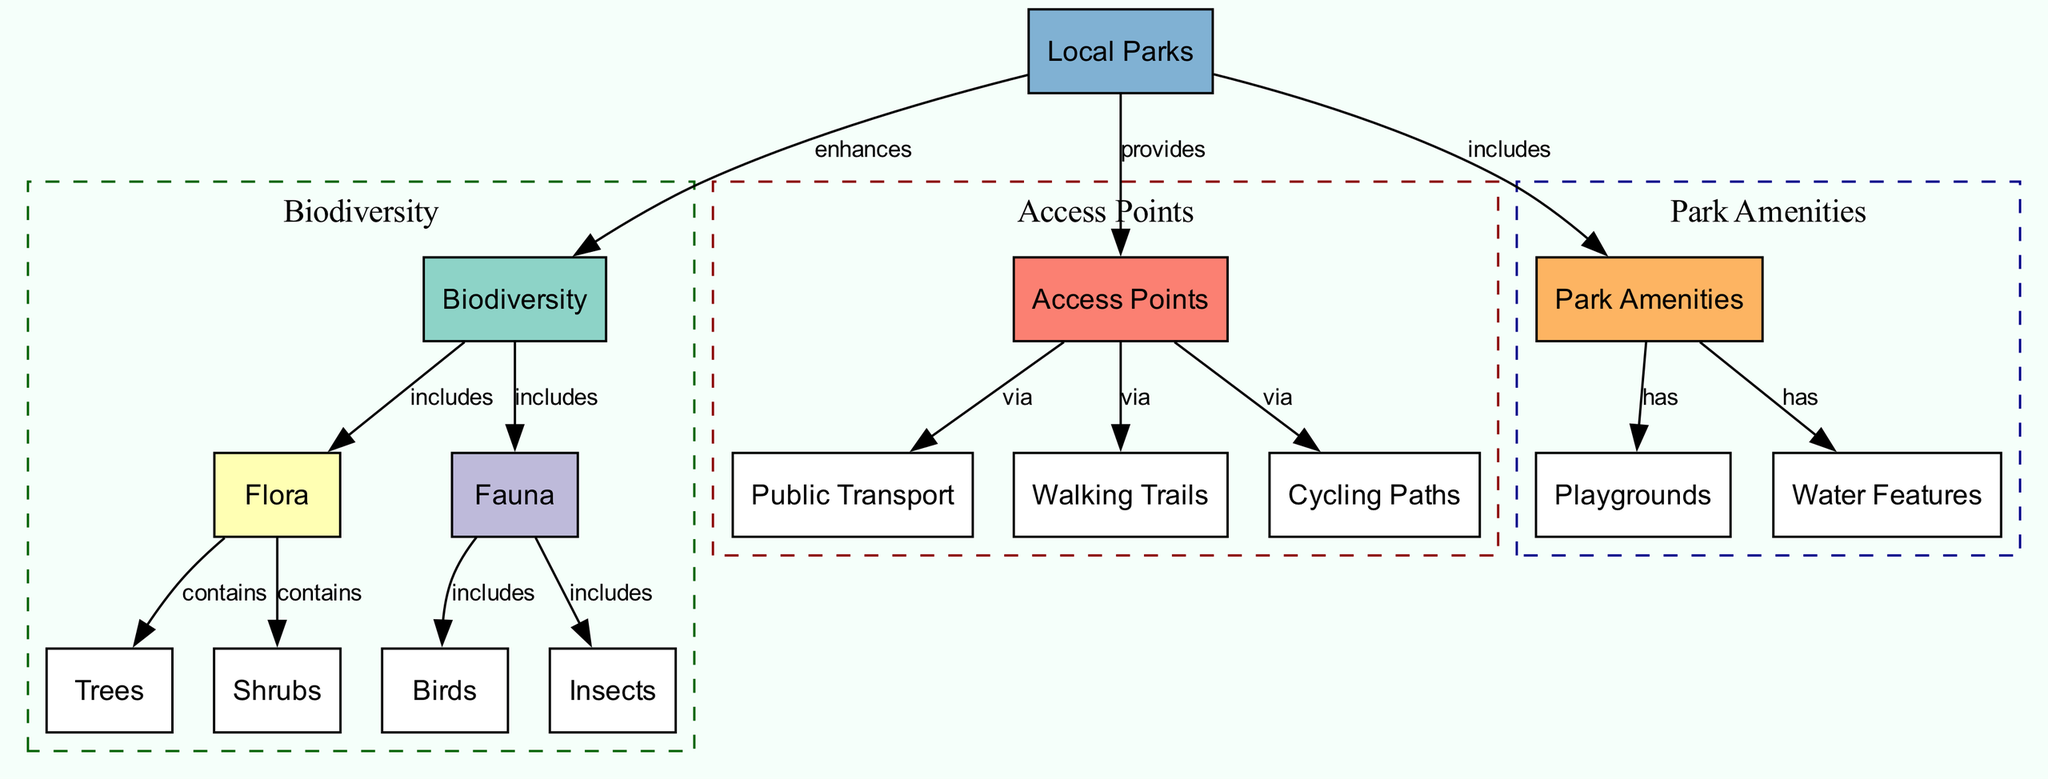What are the main components of biodiversity in the diagram? The main components of biodiversity as shown in the diagram are flora and fauna. These two categories are directly included in the "Biodiversity" node, which establishes their significance within the broader concept.
Answer: flora and fauna How many access points are listed in the diagram? The diagram displays one main node labeled "access points," which connects to public transport, walking trails, and cycling paths. It is calculated as the primary access facilitator without counting those sub-nodes, leading to a total of one access point.
Answer: 1 Which nodes are connected to the local parks node? The local parks node connects to three nodes: biodiversity, access points, and park amenities. The connections indicate that local parks enhance biodiversity, provide access points, and include park amenities, which encompass additional features and facilities.
Answer: biodiversity, access points, park amenities What flora categories are included under biodiversity? Within the biodiversity node, two specific flora categories are highlighted: trees and shrubs. These categories are described as elements that "contain" the broader topic of flora, emphasizing the variety of plant life in urban green spaces.
Answer: trees, shrubs Which access points are connected via walking trails? The walking trails node is a direct sub-node of access points, indicating that walking trails exist as one means of access to local parks. This established connection affirms walking trails as part of the pathway system available to park visitors.
Answer: walking trails How many species of fauna are listed in the biodiversity section? The biodiversity section mentions two species under fauna: birds and insects. This clearly defines the diversity of animal life present within the ecosystem of local parks, emphasizing the significance of fauna alongside flora.
Answer: 2 What amenities are included under park amenities? Under park amenities, two specific amenities are included: playgrounds and water features. This division highlights recreational and aesthetic elements that enhance the user experience in local parks, indicating their importance in community engagement.
Answer: playgrounds, water features What relationships exist between access points and local parks? The relationships highlight that access points provide connections to public transport, walking trails, and cycling paths, enhancing access to local parks. This indicates the importance of these access points for ensuring people can reach the parks conveniently.
Answer: provides Which node is the starting point for understanding park amenities? The starting point for understanding park amenities is the "park amenities" node itself. It directly connects to the specific amenities such as playgrounds and water features, organizing information around these additional features in local parks.
Answer: park amenities 